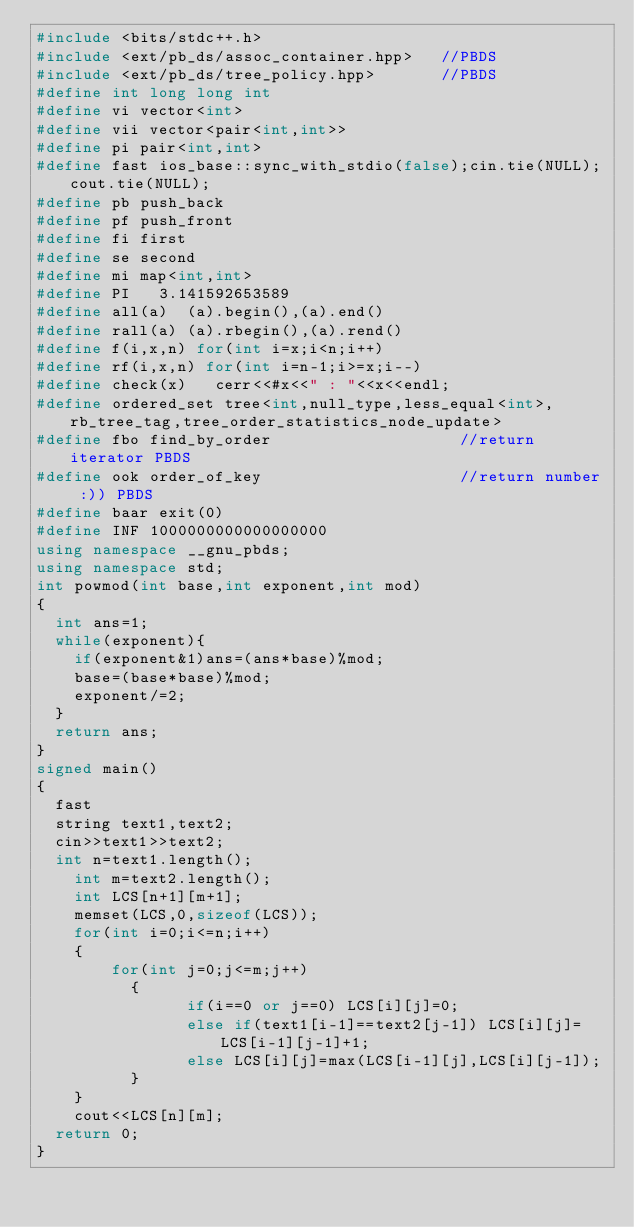<code> <loc_0><loc_0><loc_500><loc_500><_C++_>#include <bits/stdc++.h>
#include <ext/pb_ds/assoc_container.hpp>   //PBDS
#include <ext/pb_ds/tree_policy.hpp>       //PBDS
#define int long long int
#define vi vector<int>
#define vii vector<pair<int,int>>
#define pi pair<int,int>
#define fast ios_base::sync_with_stdio(false);cin.tie(NULL);cout.tie(NULL);
#define pb push_back
#define pf push_front
#define fi first
#define se second
#define mi map<int,int>
#define PI   3.141592653589
#define all(a)  (a).begin(),(a).end()
#define rall(a) (a).rbegin(),(a).rend()
#define f(i,x,n) for(int i=x;i<n;i++)
#define rf(i,x,n) for(int i=n-1;i>=x;i--)
#define check(x)   cerr<<#x<<" : "<<x<<endl;
#define ordered_set tree<int,null_type,less_equal<int>,rb_tree_tag,tree_order_statistics_node_update>
#define fbo find_by_order                    //return iterator PBDS
#define ook order_of_key                     //return number :)) PBDS
#define baar exit(0)
#define INF 1000000000000000000
using namespace __gnu_pbds;
using namespace std;
int powmod(int base,int exponent,int mod)
{
	int ans=1;
	while(exponent){
		if(exponent&1)ans=(ans*base)%mod;
		base=(base*base)%mod;
		exponent/=2;
	}
	return ans;
}
signed main()
{
	fast
	string text1,text2;
	cin>>text1>>text2;
	int n=text1.length();
    int m=text2.length();
    int LCS[n+1][m+1];
    memset(LCS,0,sizeof(LCS));
    for(int i=0;i<=n;i++)
    {
        for(int j=0;j<=m;j++)
          {
                if(i==0 or j==0) LCS[i][j]=0;
                else if(text1[i-1]==text2[j-1]) LCS[i][j]=LCS[i-1][j-1]+1;
                else LCS[i][j]=max(LCS[i-1][j],LCS[i][j-1]);
          }
    }
    cout<<LCS[n][m];
	return 0;
}</code> 